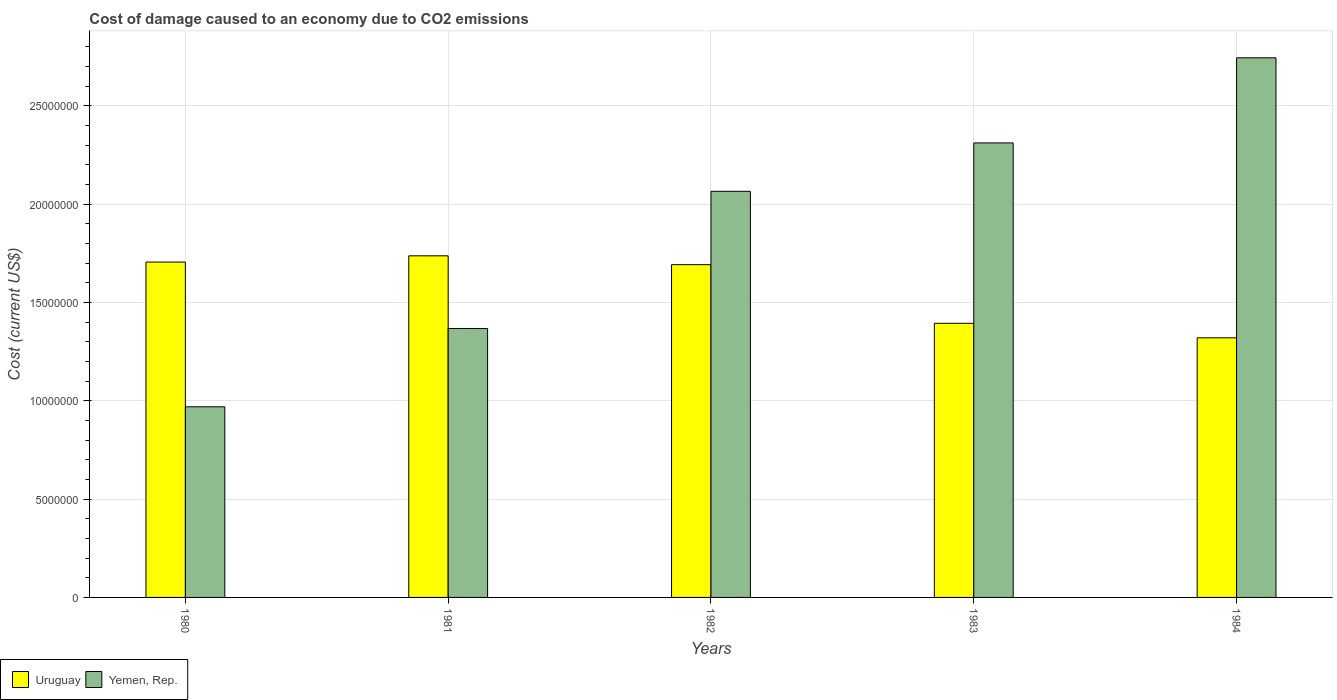Are the number of bars per tick equal to the number of legend labels?
Your response must be concise. Yes. How many bars are there on the 3rd tick from the left?
Keep it short and to the point. 2. How many bars are there on the 5th tick from the right?
Your answer should be very brief. 2. What is the label of the 5th group of bars from the left?
Offer a terse response. 1984. What is the cost of damage caused due to CO2 emissisons in Yemen, Rep. in 1982?
Keep it short and to the point. 2.07e+07. Across all years, what is the maximum cost of damage caused due to CO2 emissisons in Yemen, Rep.?
Your answer should be very brief. 2.74e+07. Across all years, what is the minimum cost of damage caused due to CO2 emissisons in Uruguay?
Make the answer very short. 1.32e+07. What is the total cost of damage caused due to CO2 emissisons in Uruguay in the graph?
Offer a terse response. 7.85e+07. What is the difference between the cost of damage caused due to CO2 emissisons in Yemen, Rep. in 1980 and that in 1982?
Your answer should be compact. -1.10e+07. What is the difference between the cost of damage caused due to CO2 emissisons in Yemen, Rep. in 1983 and the cost of damage caused due to CO2 emissisons in Uruguay in 1984?
Your answer should be very brief. 9.91e+06. What is the average cost of damage caused due to CO2 emissisons in Yemen, Rep. per year?
Make the answer very short. 1.89e+07. In the year 1984, what is the difference between the cost of damage caused due to CO2 emissisons in Yemen, Rep. and cost of damage caused due to CO2 emissisons in Uruguay?
Keep it short and to the point. 1.42e+07. In how many years, is the cost of damage caused due to CO2 emissisons in Uruguay greater than 21000000 US$?
Give a very brief answer. 0. What is the ratio of the cost of damage caused due to CO2 emissisons in Yemen, Rep. in 1983 to that in 1984?
Offer a terse response. 0.84. Is the cost of damage caused due to CO2 emissisons in Uruguay in 1982 less than that in 1983?
Make the answer very short. No. What is the difference between the highest and the second highest cost of damage caused due to CO2 emissisons in Uruguay?
Offer a very short reply. 3.18e+05. What is the difference between the highest and the lowest cost of damage caused due to CO2 emissisons in Yemen, Rep.?
Offer a terse response. 1.78e+07. In how many years, is the cost of damage caused due to CO2 emissisons in Uruguay greater than the average cost of damage caused due to CO2 emissisons in Uruguay taken over all years?
Keep it short and to the point. 3. What does the 1st bar from the left in 1983 represents?
Provide a short and direct response. Uruguay. What does the 1st bar from the right in 1983 represents?
Your answer should be very brief. Yemen, Rep. How many bars are there?
Offer a very short reply. 10. How many years are there in the graph?
Make the answer very short. 5. What is the difference between two consecutive major ticks on the Y-axis?
Keep it short and to the point. 5.00e+06. Are the values on the major ticks of Y-axis written in scientific E-notation?
Make the answer very short. No. Does the graph contain any zero values?
Provide a short and direct response. No. Does the graph contain grids?
Your answer should be very brief. Yes. Where does the legend appear in the graph?
Provide a short and direct response. Bottom left. How many legend labels are there?
Provide a succinct answer. 2. What is the title of the graph?
Ensure brevity in your answer.  Cost of damage caused to an economy due to CO2 emissions. What is the label or title of the X-axis?
Your answer should be compact. Years. What is the label or title of the Y-axis?
Give a very brief answer. Cost (current US$). What is the Cost (current US$) in Uruguay in 1980?
Your answer should be compact. 1.71e+07. What is the Cost (current US$) in Yemen, Rep. in 1980?
Offer a very short reply. 9.70e+06. What is the Cost (current US$) of Uruguay in 1981?
Ensure brevity in your answer.  1.74e+07. What is the Cost (current US$) in Yemen, Rep. in 1981?
Provide a succinct answer. 1.37e+07. What is the Cost (current US$) of Uruguay in 1982?
Your answer should be compact. 1.69e+07. What is the Cost (current US$) of Yemen, Rep. in 1982?
Keep it short and to the point. 2.07e+07. What is the Cost (current US$) in Uruguay in 1983?
Your answer should be very brief. 1.39e+07. What is the Cost (current US$) of Yemen, Rep. in 1983?
Make the answer very short. 2.31e+07. What is the Cost (current US$) in Uruguay in 1984?
Make the answer very short. 1.32e+07. What is the Cost (current US$) in Yemen, Rep. in 1984?
Provide a succinct answer. 2.74e+07. Across all years, what is the maximum Cost (current US$) of Uruguay?
Keep it short and to the point. 1.74e+07. Across all years, what is the maximum Cost (current US$) in Yemen, Rep.?
Provide a short and direct response. 2.74e+07. Across all years, what is the minimum Cost (current US$) in Uruguay?
Offer a very short reply. 1.32e+07. Across all years, what is the minimum Cost (current US$) in Yemen, Rep.?
Give a very brief answer. 9.70e+06. What is the total Cost (current US$) of Uruguay in the graph?
Give a very brief answer. 7.85e+07. What is the total Cost (current US$) of Yemen, Rep. in the graph?
Ensure brevity in your answer.  9.46e+07. What is the difference between the Cost (current US$) of Uruguay in 1980 and that in 1981?
Ensure brevity in your answer.  -3.18e+05. What is the difference between the Cost (current US$) of Yemen, Rep. in 1980 and that in 1981?
Ensure brevity in your answer.  -3.98e+06. What is the difference between the Cost (current US$) in Uruguay in 1980 and that in 1982?
Your response must be concise. 1.32e+05. What is the difference between the Cost (current US$) of Yemen, Rep. in 1980 and that in 1982?
Keep it short and to the point. -1.10e+07. What is the difference between the Cost (current US$) of Uruguay in 1980 and that in 1983?
Provide a short and direct response. 3.11e+06. What is the difference between the Cost (current US$) of Yemen, Rep. in 1980 and that in 1983?
Make the answer very short. -1.34e+07. What is the difference between the Cost (current US$) of Uruguay in 1980 and that in 1984?
Your answer should be very brief. 3.85e+06. What is the difference between the Cost (current US$) in Yemen, Rep. in 1980 and that in 1984?
Your answer should be compact. -1.78e+07. What is the difference between the Cost (current US$) of Uruguay in 1981 and that in 1982?
Your answer should be compact. 4.50e+05. What is the difference between the Cost (current US$) of Yemen, Rep. in 1981 and that in 1982?
Make the answer very short. -6.98e+06. What is the difference between the Cost (current US$) of Uruguay in 1981 and that in 1983?
Your response must be concise. 3.43e+06. What is the difference between the Cost (current US$) of Yemen, Rep. in 1981 and that in 1983?
Offer a very short reply. -9.44e+06. What is the difference between the Cost (current US$) in Uruguay in 1981 and that in 1984?
Your answer should be very brief. 4.17e+06. What is the difference between the Cost (current US$) in Yemen, Rep. in 1981 and that in 1984?
Provide a short and direct response. -1.38e+07. What is the difference between the Cost (current US$) of Uruguay in 1982 and that in 1983?
Your answer should be very brief. 2.98e+06. What is the difference between the Cost (current US$) in Yemen, Rep. in 1982 and that in 1983?
Your answer should be compact. -2.46e+06. What is the difference between the Cost (current US$) of Uruguay in 1982 and that in 1984?
Offer a terse response. 3.72e+06. What is the difference between the Cost (current US$) of Yemen, Rep. in 1982 and that in 1984?
Make the answer very short. -6.79e+06. What is the difference between the Cost (current US$) of Uruguay in 1983 and that in 1984?
Ensure brevity in your answer.  7.39e+05. What is the difference between the Cost (current US$) in Yemen, Rep. in 1983 and that in 1984?
Your answer should be compact. -4.33e+06. What is the difference between the Cost (current US$) in Uruguay in 1980 and the Cost (current US$) in Yemen, Rep. in 1981?
Your answer should be compact. 3.38e+06. What is the difference between the Cost (current US$) of Uruguay in 1980 and the Cost (current US$) of Yemen, Rep. in 1982?
Offer a very short reply. -3.60e+06. What is the difference between the Cost (current US$) of Uruguay in 1980 and the Cost (current US$) of Yemen, Rep. in 1983?
Provide a short and direct response. -6.06e+06. What is the difference between the Cost (current US$) of Uruguay in 1980 and the Cost (current US$) of Yemen, Rep. in 1984?
Make the answer very short. -1.04e+07. What is the difference between the Cost (current US$) in Uruguay in 1981 and the Cost (current US$) in Yemen, Rep. in 1982?
Give a very brief answer. -3.28e+06. What is the difference between the Cost (current US$) of Uruguay in 1981 and the Cost (current US$) of Yemen, Rep. in 1983?
Keep it short and to the point. -5.74e+06. What is the difference between the Cost (current US$) in Uruguay in 1981 and the Cost (current US$) in Yemen, Rep. in 1984?
Provide a short and direct response. -1.01e+07. What is the difference between the Cost (current US$) in Uruguay in 1982 and the Cost (current US$) in Yemen, Rep. in 1983?
Make the answer very short. -6.19e+06. What is the difference between the Cost (current US$) in Uruguay in 1982 and the Cost (current US$) in Yemen, Rep. in 1984?
Provide a short and direct response. -1.05e+07. What is the difference between the Cost (current US$) of Uruguay in 1983 and the Cost (current US$) of Yemen, Rep. in 1984?
Give a very brief answer. -1.35e+07. What is the average Cost (current US$) of Uruguay per year?
Give a very brief answer. 1.57e+07. What is the average Cost (current US$) of Yemen, Rep. per year?
Your answer should be compact. 1.89e+07. In the year 1980, what is the difference between the Cost (current US$) in Uruguay and Cost (current US$) in Yemen, Rep.?
Offer a terse response. 7.36e+06. In the year 1981, what is the difference between the Cost (current US$) in Uruguay and Cost (current US$) in Yemen, Rep.?
Your response must be concise. 3.70e+06. In the year 1982, what is the difference between the Cost (current US$) of Uruguay and Cost (current US$) of Yemen, Rep.?
Make the answer very short. -3.73e+06. In the year 1983, what is the difference between the Cost (current US$) in Uruguay and Cost (current US$) in Yemen, Rep.?
Your answer should be compact. -9.18e+06. In the year 1984, what is the difference between the Cost (current US$) in Uruguay and Cost (current US$) in Yemen, Rep.?
Your response must be concise. -1.42e+07. What is the ratio of the Cost (current US$) in Uruguay in 1980 to that in 1981?
Your answer should be very brief. 0.98. What is the ratio of the Cost (current US$) of Yemen, Rep. in 1980 to that in 1981?
Offer a terse response. 0.71. What is the ratio of the Cost (current US$) of Yemen, Rep. in 1980 to that in 1982?
Ensure brevity in your answer.  0.47. What is the ratio of the Cost (current US$) of Uruguay in 1980 to that in 1983?
Give a very brief answer. 1.22. What is the ratio of the Cost (current US$) in Yemen, Rep. in 1980 to that in 1983?
Offer a very short reply. 0.42. What is the ratio of the Cost (current US$) in Uruguay in 1980 to that in 1984?
Make the answer very short. 1.29. What is the ratio of the Cost (current US$) of Yemen, Rep. in 1980 to that in 1984?
Provide a short and direct response. 0.35. What is the ratio of the Cost (current US$) in Uruguay in 1981 to that in 1982?
Your answer should be very brief. 1.03. What is the ratio of the Cost (current US$) in Yemen, Rep. in 1981 to that in 1982?
Your response must be concise. 0.66. What is the ratio of the Cost (current US$) of Uruguay in 1981 to that in 1983?
Your response must be concise. 1.25. What is the ratio of the Cost (current US$) of Yemen, Rep. in 1981 to that in 1983?
Keep it short and to the point. 0.59. What is the ratio of the Cost (current US$) of Uruguay in 1981 to that in 1984?
Offer a terse response. 1.32. What is the ratio of the Cost (current US$) in Yemen, Rep. in 1981 to that in 1984?
Offer a terse response. 0.5. What is the ratio of the Cost (current US$) of Uruguay in 1982 to that in 1983?
Offer a very short reply. 1.21. What is the ratio of the Cost (current US$) in Yemen, Rep. in 1982 to that in 1983?
Provide a short and direct response. 0.89. What is the ratio of the Cost (current US$) in Uruguay in 1982 to that in 1984?
Your answer should be compact. 1.28. What is the ratio of the Cost (current US$) of Yemen, Rep. in 1982 to that in 1984?
Keep it short and to the point. 0.75. What is the ratio of the Cost (current US$) in Uruguay in 1983 to that in 1984?
Your response must be concise. 1.06. What is the ratio of the Cost (current US$) of Yemen, Rep. in 1983 to that in 1984?
Ensure brevity in your answer.  0.84. What is the difference between the highest and the second highest Cost (current US$) of Uruguay?
Give a very brief answer. 3.18e+05. What is the difference between the highest and the second highest Cost (current US$) in Yemen, Rep.?
Provide a short and direct response. 4.33e+06. What is the difference between the highest and the lowest Cost (current US$) in Uruguay?
Give a very brief answer. 4.17e+06. What is the difference between the highest and the lowest Cost (current US$) of Yemen, Rep.?
Give a very brief answer. 1.78e+07. 